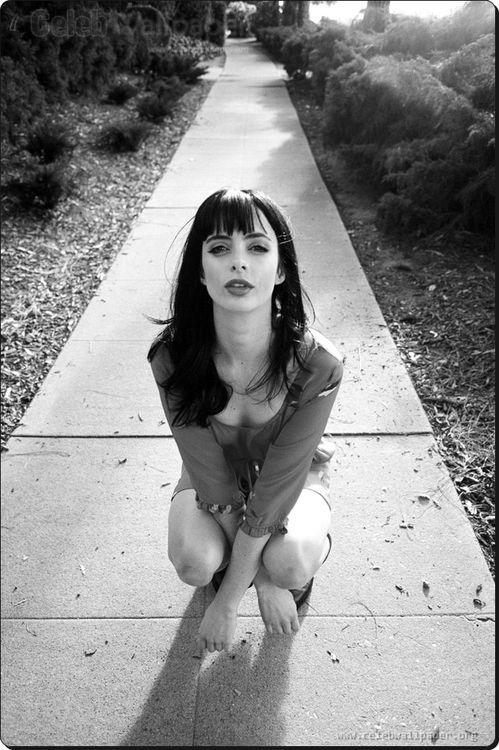Create a short story inspired by this image. On a quiet, lonely sidewalk, Eliza knelt down, her mind racing through memories she wished to forget. The black and white world around her seemed to freeze, capturing her in this moment of vulnerability. For years, she had run from her past, trying to bury the secrets deep within. But now, the time had come to face her demons. Her intense gaze seemed to pierce through the very fabric of reality, reaching into the hidden corners of her soul. As she knelt there, she made a silent vow - to confront the shadows that had haunted her for so long and to reclaim her life from the darkness. 